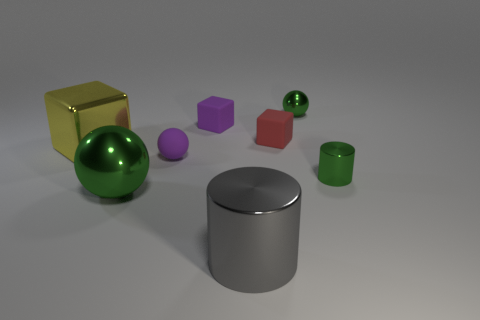Do the cylinder that is in front of the big green metal ball and the yellow thing have the same material? Based on the visual cues in the image, the cylinder in front of the big green metal ball appears to have a reflective, metallic surface which suggests that it's made of metal. The yellow object, which seems to be a cube, also has a reflective surface, but without additional context or information, it's not possible to confirm with certainty if it's made from the same exact material as the cylinder. They both exhibit properties consistent with metal due to their reflective nature, but we would need more information to conclusively determine if they are the same material. 